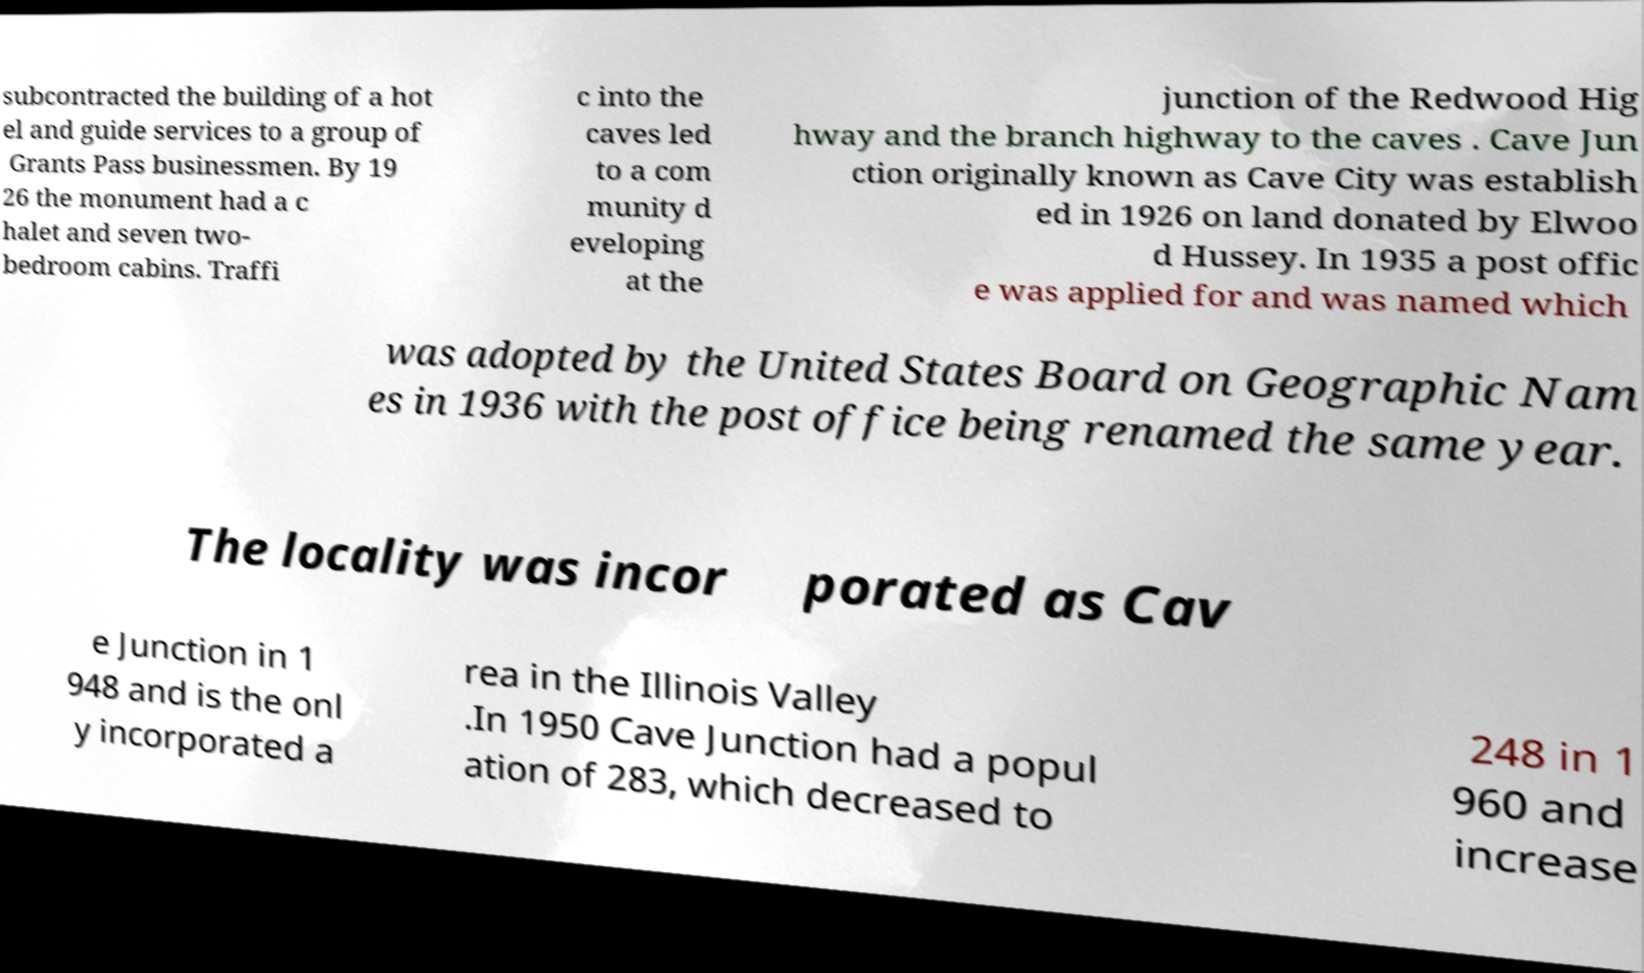For documentation purposes, I need the text within this image transcribed. Could you provide that? subcontracted the building of a hot el and guide services to a group of Grants Pass businessmen. By 19 26 the monument had a c halet and seven two- bedroom cabins. Traffi c into the caves led to a com munity d eveloping at the junction of the Redwood Hig hway and the branch highway to the caves . Cave Jun ction originally known as Cave City was establish ed in 1926 on land donated by Elwoo d Hussey. In 1935 a post offic e was applied for and was named which was adopted by the United States Board on Geographic Nam es in 1936 with the post office being renamed the same year. The locality was incor porated as Cav e Junction in 1 948 and is the onl y incorporated a rea in the Illinois Valley .In 1950 Cave Junction had a popul ation of 283, which decreased to 248 in 1 960 and increase 